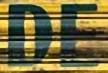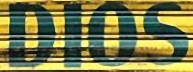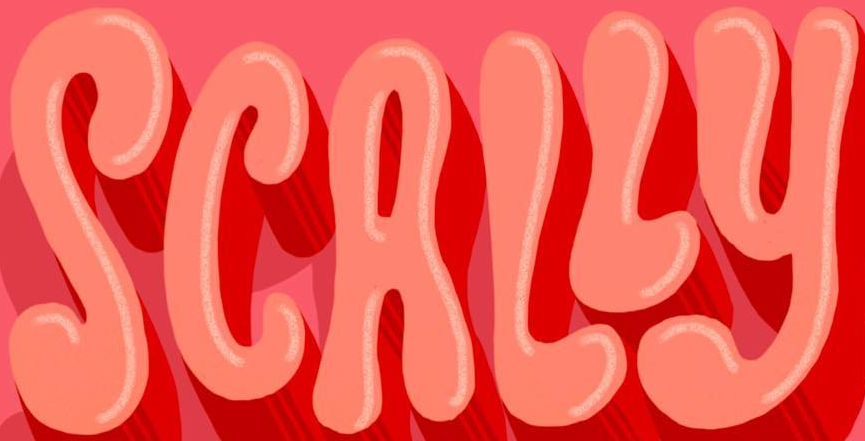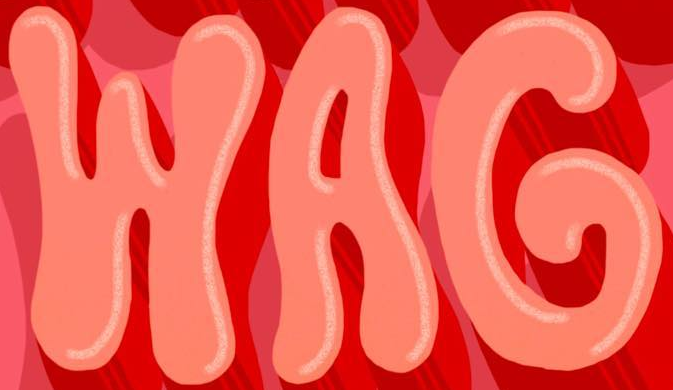Read the text content from these images in order, separated by a semicolon. DE; DIOS; SCALLY; WAG 